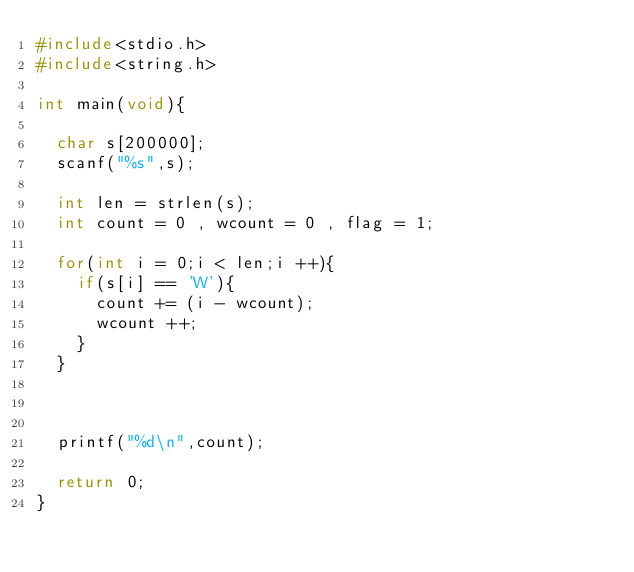<code> <loc_0><loc_0><loc_500><loc_500><_C_>#include<stdio.h>
#include<string.h>

int main(void){

  char s[200000];
  scanf("%s",s);

  int len = strlen(s);
  int count = 0 , wcount = 0 , flag = 1;
  
  for(int i = 0;i < len;i ++){
    if(s[i] == 'W'){
      count += (i - wcount);
      wcount ++;
    }
  }

  

  printf("%d\n",count);

  return 0;
}</code> 